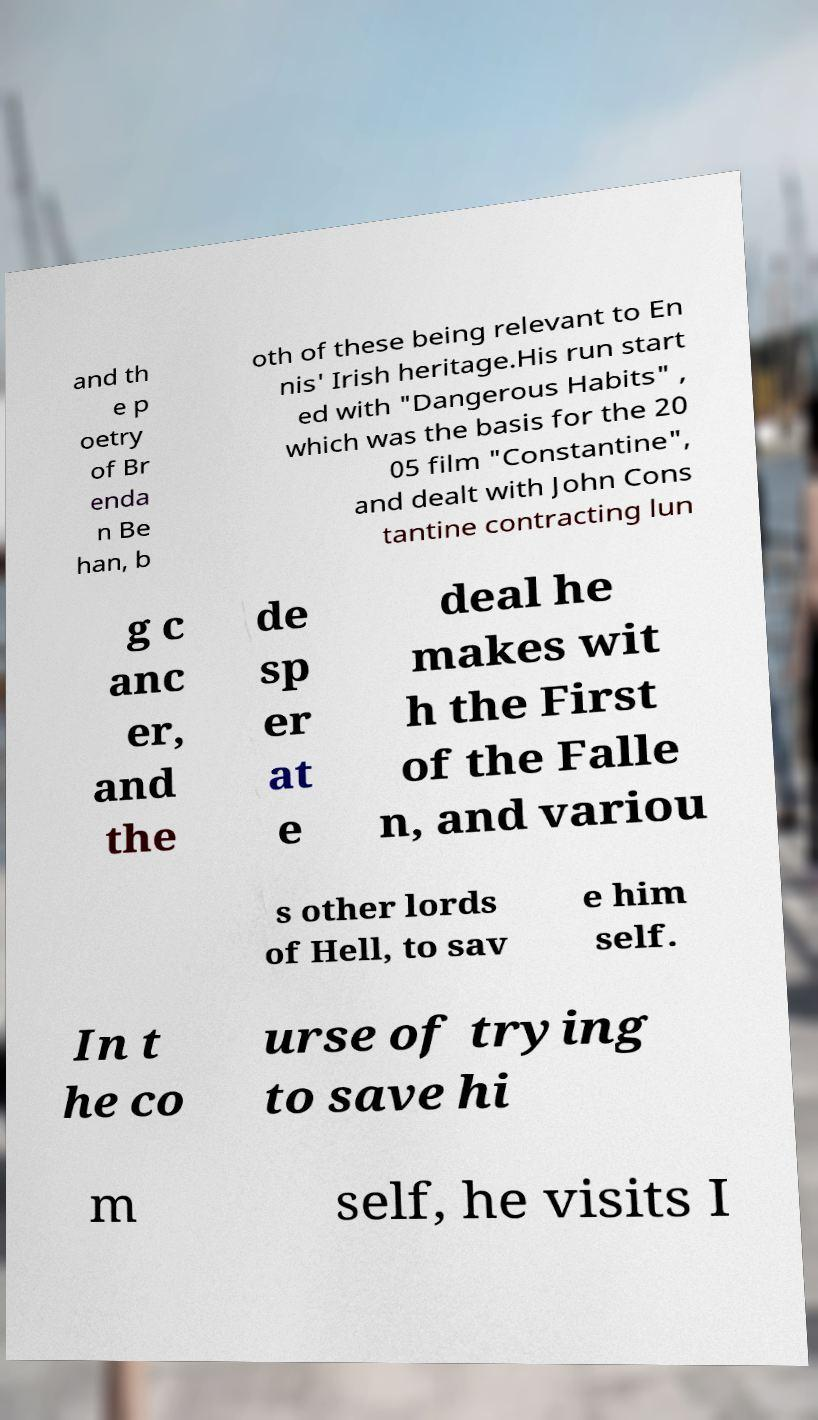Please identify and transcribe the text found in this image. and th e p oetry of Br enda n Be han, b oth of these being relevant to En nis' Irish heritage.His run start ed with "Dangerous Habits" , which was the basis for the 20 05 film "Constantine", and dealt with John Cons tantine contracting lun g c anc er, and the de sp er at e deal he makes wit h the First of the Falle n, and variou s other lords of Hell, to sav e him self. In t he co urse of trying to save hi m self, he visits I 